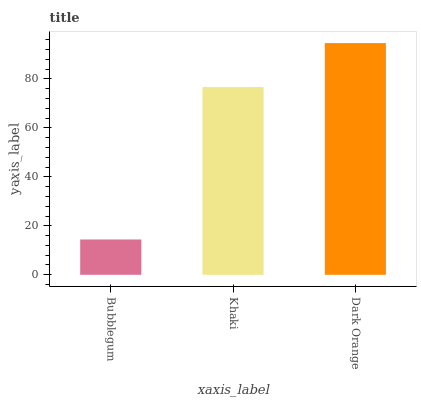Is Bubblegum the minimum?
Answer yes or no. Yes. Is Dark Orange the maximum?
Answer yes or no. Yes. Is Khaki the minimum?
Answer yes or no. No. Is Khaki the maximum?
Answer yes or no. No. Is Khaki greater than Bubblegum?
Answer yes or no. Yes. Is Bubblegum less than Khaki?
Answer yes or no. Yes. Is Bubblegum greater than Khaki?
Answer yes or no. No. Is Khaki less than Bubblegum?
Answer yes or no. No. Is Khaki the high median?
Answer yes or no. Yes. Is Khaki the low median?
Answer yes or no. Yes. Is Bubblegum the high median?
Answer yes or no. No. Is Bubblegum the low median?
Answer yes or no. No. 